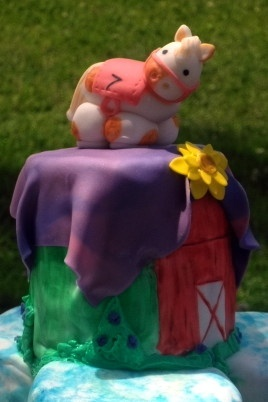Describe the objects in this image and their specific colors. I can see a cake in darkgreen, black, maroon, and gray tones in this image. 